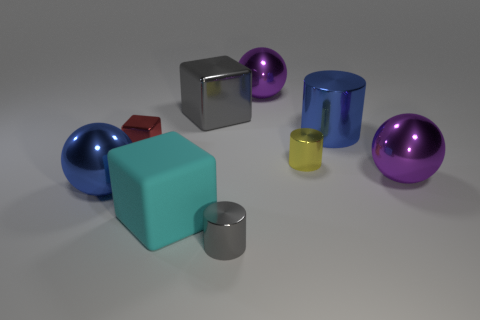Subtract all brown cubes. Subtract all brown spheres. How many cubes are left? 3 Subtract all gray balls. How many yellow blocks are left? 0 Add 7 reds. How many objects exist? 0 Subtract all large rubber cubes. Subtract all small things. How many objects are left? 5 Add 1 large cylinders. How many large cylinders are left? 2 Add 7 red things. How many red things exist? 8 Add 1 gray metallic objects. How many objects exist? 10 Subtract all blue cylinders. How many cylinders are left? 2 Subtract all large cylinders. How many cylinders are left? 2 Subtract 1 yellow cylinders. How many objects are left? 8 